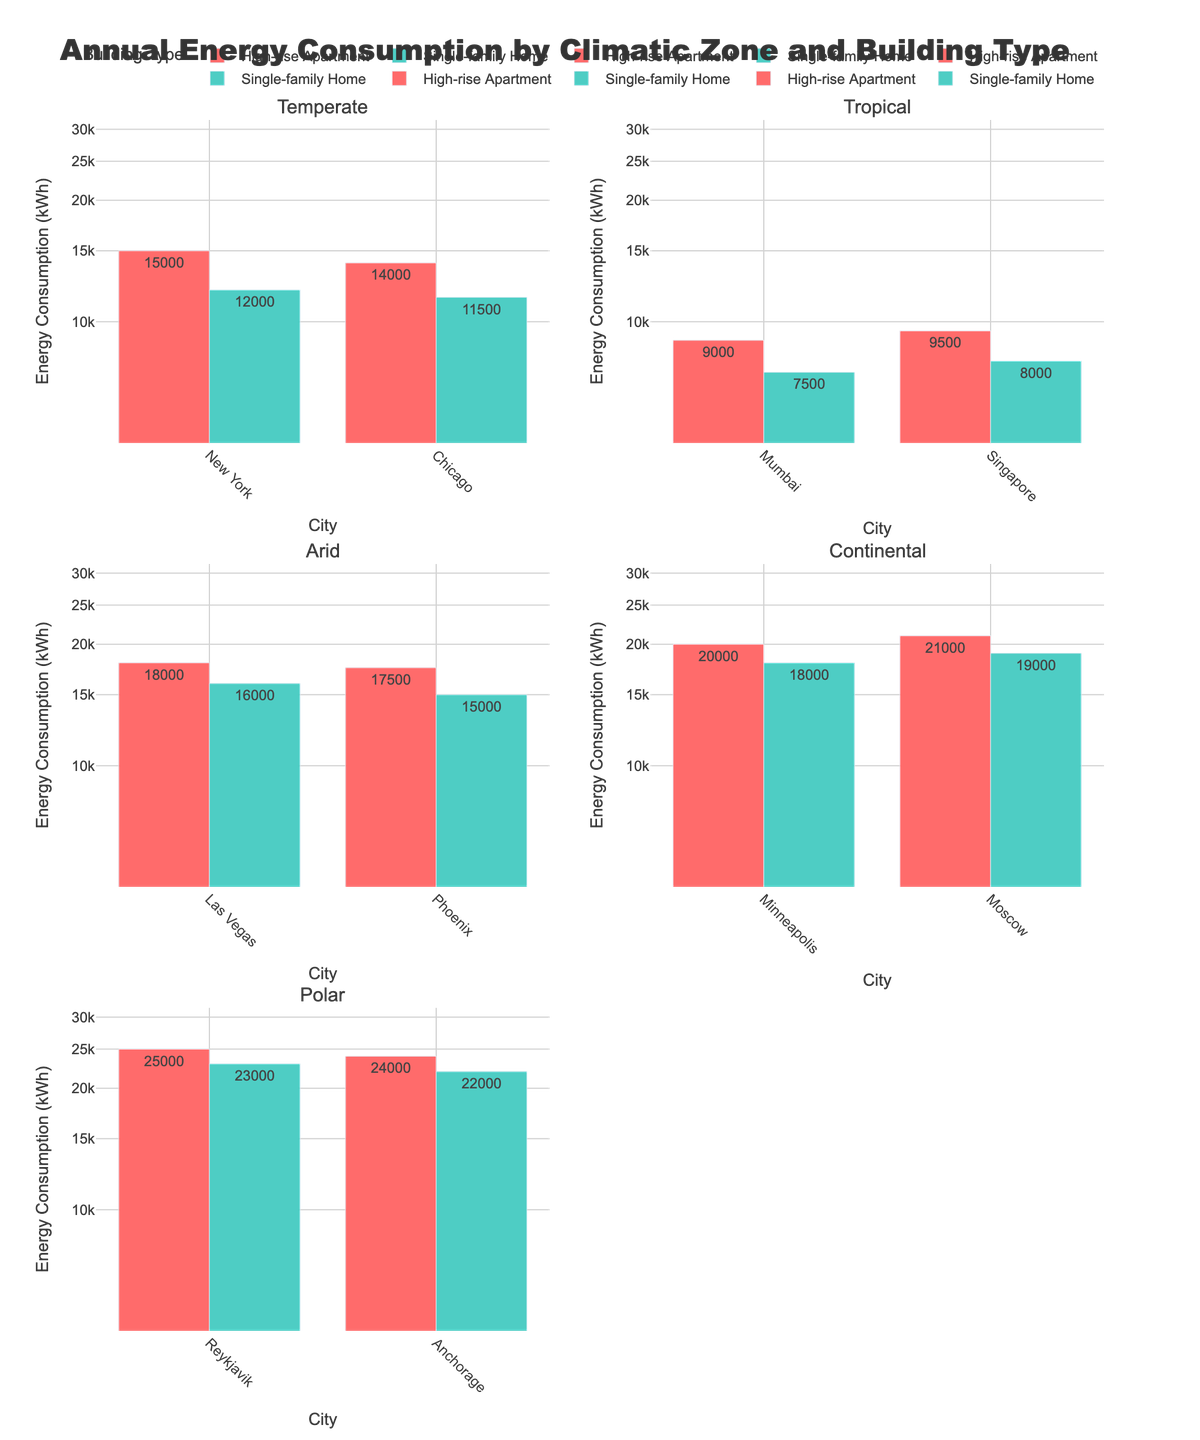What's the plot title? The plot title is located at the top of the figure. It summarizes the content of the figure.
Answer: Annual Energy Consumption by Climatic Zone and Building Type What type of axis scaling is used on the y-axis? The y-axis scaling is indicated with a logarithmic annotation, which is visible from the non-linear spacing of the tick marks.
Answer: Logarithmic Which building type in the Tropical climatic zone uses the least energy annually? By comparing the heights of the bars for the different building types within the Tropical climatic zone subplot, we can identify the shortest bar.
Answer: Single-family Home What is the difference in energy consumption between high-rise apartments in Las Vegas and Phoenix? Locate bars representing Las Vegas and Phoenix in the Arid climatic zone subplot. Subtract the shorter bar's value from the taller bar's value.
Answer: 500 kWh Which city in the Polar climatic zone has the highest annual energy consumption for high-rise apartments? Check the heights of the bars representing high-rise apartments in the subplot for the Polar climatic zone and find the tallest one.
Answer: Reykjavik Are there any cities where the energy consumption for single-family homes and high-rise apartments is the same? Review each subplot to see if any city has equally tall bars for both residential building types.
Answer: No Which climatic zone has the highest average energy consumption for single-family homes? Calculate the average energy consumption for single-family homes in each climatic zone and compare the results. The Continental zone has an average of (18000 + 19000)/2 = 18500 kWh, which is higher than the others.
Answer: Continental In the Temperate climatic zone, which city consumes more energy for high-rise apartments? Compare the heights of the bars for high-rise apartments in New York and Chicago within the Temperate climatic zone subplot.
Answer: New York How many climatic zones are displayed in the figure? Count the number of subplot titles, each representing a different climatic zone.
Answer: Five How does the energy consumption of high-rise apartments in Moscow compare to those in Minneapolis? Compare the heights of the bars representing high-rise apartments in both cities in the Continental climatic zone subplot. Minneapolis has a bar height of 20000, and Moscow has 21000, so Moscow's consumption is higher.
Answer: Moscow 